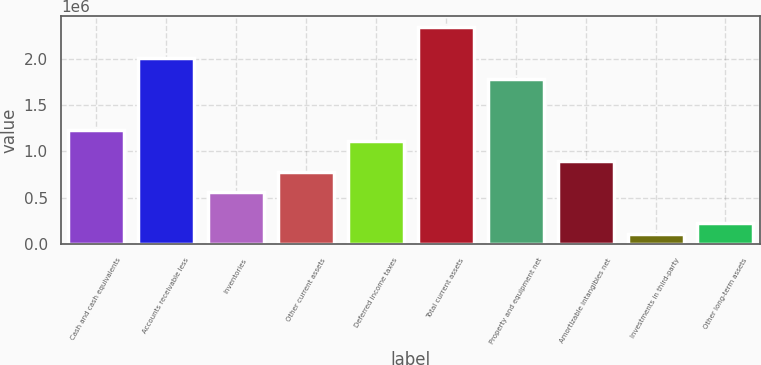<chart> <loc_0><loc_0><loc_500><loc_500><bar_chart><fcel>Cash and cash equivalents<fcel>Accounts receivable less<fcel>Inventories<fcel>Other current assets<fcel>Deferred income taxes<fcel>Total current assets<fcel>Property and equipment net<fcel>Amortizable intangibles net<fcel>Investments in third-party<fcel>Other long-term assets<nl><fcel>1.22869e+06<fcel>2.01053e+06<fcel>558546<fcel>781928<fcel>1.117e+06<fcel>2.34561e+06<fcel>1.78715e+06<fcel>893620<fcel>111781<fcel>223472<nl></chart> 